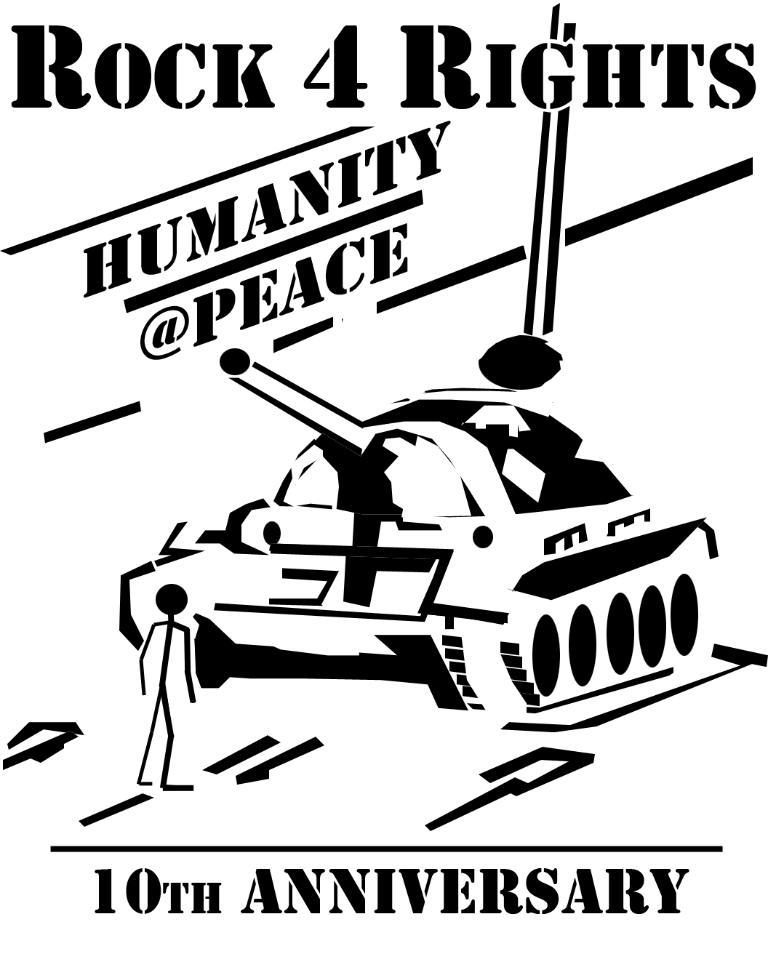What is depicted on the poster in the image? The poster contains a military tank and a person. What type of vehicle is shown on the poster? The vehicle shown on the poster is a military tank. Is there any text on the poster? Yes, there is text written on the poster. How many brothers are depicted in the image? There are no brothers depicted in the image; the poster contains a military tank and a person. What scientific discovery is shown in the image? There is no scientific discovery depicted in the image; the poster contains a military tank and a person. 